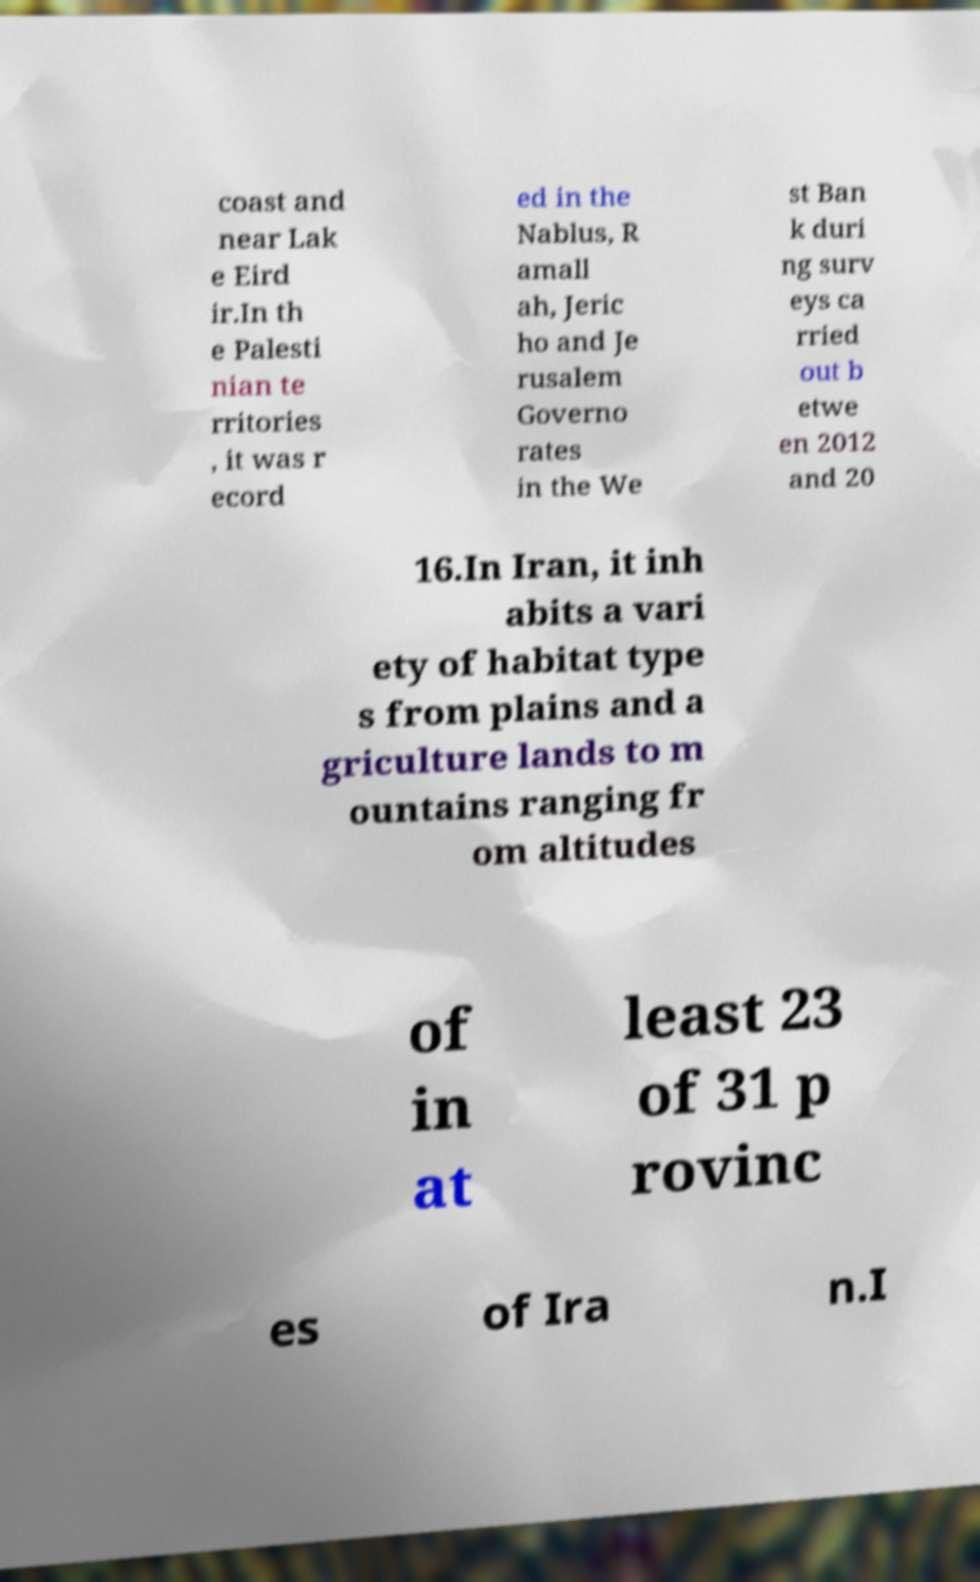What messages or text are displayed in this image? I need them in a readable, typed format. coast and near Lak e Eird ir.In th e Palesti nian te rritories , it was r ecord ed in the Nablus, R amall ah, Jeric ho and Je rusalem Governo rates in the We st Ban k duri ng surv eys ca rried out b etwe en 2012 and 20 16.In Iran, it inh abits a vari ety of habitat type s from plains and a griculture lands to m ountains ranging fr om altitudes of in at least 23 of 31 p rovinc es of Ira n.I 